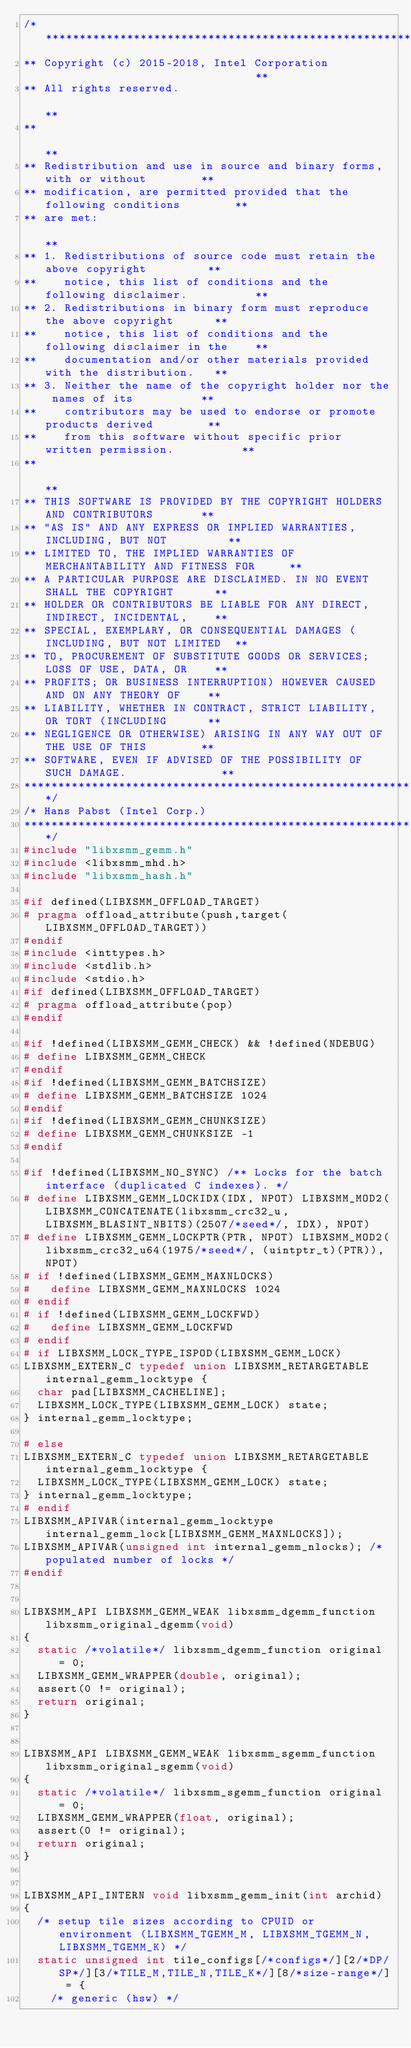<code> <loc_0><loc_0><loc_500><loc_500><_C_>/******************************************************************************
** Copyright (c) 2015-2018, Intel Corporation                                **
** All rights reserved.                                                      **
**                                                                           **
** Redistribution and use in source and binary forms, with or without        **
** modification, are permitted provided that the following conditions        **
** are met:                                                                  **
** 1. Redistributions of source code must retain the above copyright         **
**    notice, this list of conditions and the following disclaimer.          **
** 2. Redistributions in binary form must reproduce the above copyright      **
**    notice, this list of conditions and the following disclaimer in the    **
**    documentation and/or other materials provided with the distribution.   **
** 3. Neither the name of the copyright holder nor the names of its          **
**    contributors may be used to endorse or promote products derived        **
**    from this software without specific prior written permission.          **
**                                                                           **
** THIS SOFTWARE IS PROVIDED BY THE COPYRIGHT HOLDERS AND CONTRIBUTORS       **
** "AS IS" AND ANY EXPRESS OR IMPLIED WARRANTIES, INCLUDING, BUT NOT         **
** LIMITED TO, THE IMPLIED WARRANTIES OF MERCHANTABILITY AND FITNESS FOR     **
** A PARTICULAR PURPOSE ARE DISCLAIMED. IN NO EVENT SHALL THE COPYRIGHT      **
** HOLDER OR CONTRIBUTORS BE LIABLE FOR ANY DIRECT, INDIRECT, INCIDENTAL,    **
** SPECIAL, EXEMPLARY, OR CONSEQUENTIAL DAMAGES (INCLUDING, BUT NOT LIMITED  **
** TO, PROCUREMENT OF SUBSTITUTE GOODS OR SERVICES; LOSS OF USE, DATA, OR    **
** PROFITS; OR BUSINESS INTERRUPTION) HOWEVER CAUSED AND ON ANY THEORY OF    **
** LIABILITY, WHETHER IN CONTRACT, STRICT LIABILITY, OR TORT (INCLUDING      **
** NEGLIGENCE OR OTHERWISE) ARISING IN ANY WAY OUT OF THE USE OF THIS        **
** SOFTWARE, EVEN IF ADVISED OF THE POSSIBILITY OF SUCH DAMAGE.              **
******************************************************************************/
/* Hans Pabst (Intel Corp.)
******************************************************************************/
#include "libxsmm_gemm.h"
#include <libxsmm_mhd.h>
#include "libxsmm_hash.h"

#if defined(LIBXSMM_OFFLOAD_TARGET)
# pragma offload_attribute(push,target(LIBXSMM_OFFLOAD_TARGET))
#endif
#include <inttypes.h>
#include <stdlib.h>
#include <stdio.h>
#if defined(LIBXSMM_OFFLOAD_TARGET)
# pragma offload_attribute(pop)
#endif

#if !defined(LIBXSMM_GEMM_CHECK) && !defined(NDEBUG)
# define LIBXSMM_GEMM_CHECK
#endif
#if !defined(LIBXSMM_GEMM_BATCHSIZE)
# define LIBXSMM_GEMM_BATCHSIZE 1024
#endif
#if !defined(LIBXSMM_GEMM_CHUNKSIZE)
# define LIBXSMM_GEMM_CHUNKSIZE -1
#endif

#if !defined(LIBXSMM_NO_SYNC) /** Locks for the batch interface (duplicated C indexes). */
# define LIBXSMM_GEMM_LOCKIDX(IDX, NPOT) LIBXSMM_MOD2(LIBXSMM_CONCATENATE(libxsmm_crc32_u,LIBXSMM_BLASINT_NBITS)(2507/*seed*/, IDX), NPOT)
# define LIBXSMM_GEMM_LOCKPTR(PTR, NPOT) LIBXSMM_MOD2(libxsmm_crc32_u64(1975/*seed*/, (uintptr_t)(PTR)), NPOT)
# if !defined(LIBXSMM_GEMM_MAXNLOCKS)
#   define LIBXSMM_GEMM_MAXNLOCKS 1024
# endif
# if !defined(LIBXSMM_GEMM_LOCKFWD)
#   define LIBXSMM_GEMM_LOCKFWD
# endif
# if LIBXSMM_LOCK_TYPE_ISPOD(LIBXSMM_GEMM_LOCK)
LIBXSMM_EXTERN_C typedef union LIBXSMM_RETARGETABLE internal_gemm_locktype {
  char pad[LIBXSMM_CACHELINE];
  LIBXSMM_LOCK_TYPE(LIBXSMM_GEMM_LOCK) state;
} internal_gemm_locktype;

# else
LIBXSMM_EXTERN_C typedef union LIBXSMM_RETARGETABLE internal_gemm_locktype {
  LIBXSMM_LOCK_TYPE(LIBXSMM_GEMM_LOCK) state;
} internal_gemm_locktype;
# endif
LIBXSMM_APIVAR(internal_gemm_locktype internal_gemm_lock[LIBXSMM_GEMM_MAXNLOCKS]);
LIBXSMM_APIVAR(unsigned int internal_gemm_nlocks); /* populated number of locks */
#endif


LIBXSMM_API LIBXSMM_GEMM_WEAK libxsmm_dgemm_function libxsmm_original_dgemm(void)
{
  static /*volatile*/ libxsmm_dgemm_function original = 0;
  LIBXSMM_GEMM_WRAPPER(double, original);
  assert(0 != original);
  return original;
}


LIBXSMM_API LIBXSMM_GEMM_WEAK libxsmm_sgemm_function libxsmm_original_sgemm(void)
{
  static /*volatile*/ libxsmm_sgemm_function original = 0;
  LIBXSMM_GEMM_WRAPPER(float, original);
  assert(0 != original);
  return original;
}


LIBXSMM_API_INTERN void libxsmm_gemm_init(int archid)
{
  /* setup tile sizes according to CPUID or environment (LIBXSMM_TGEMM_M, LIBXSMM_TGEMM_N, LIBXSMM_TGEMM_K) */
  static unsigned int tile_configs[/*configs*/][2/*DP/SP*/][3/*TILE_M,TILE_N,TILE_K*/][8/*size-range*/] = {
    /* generic (hsw) */</code> 